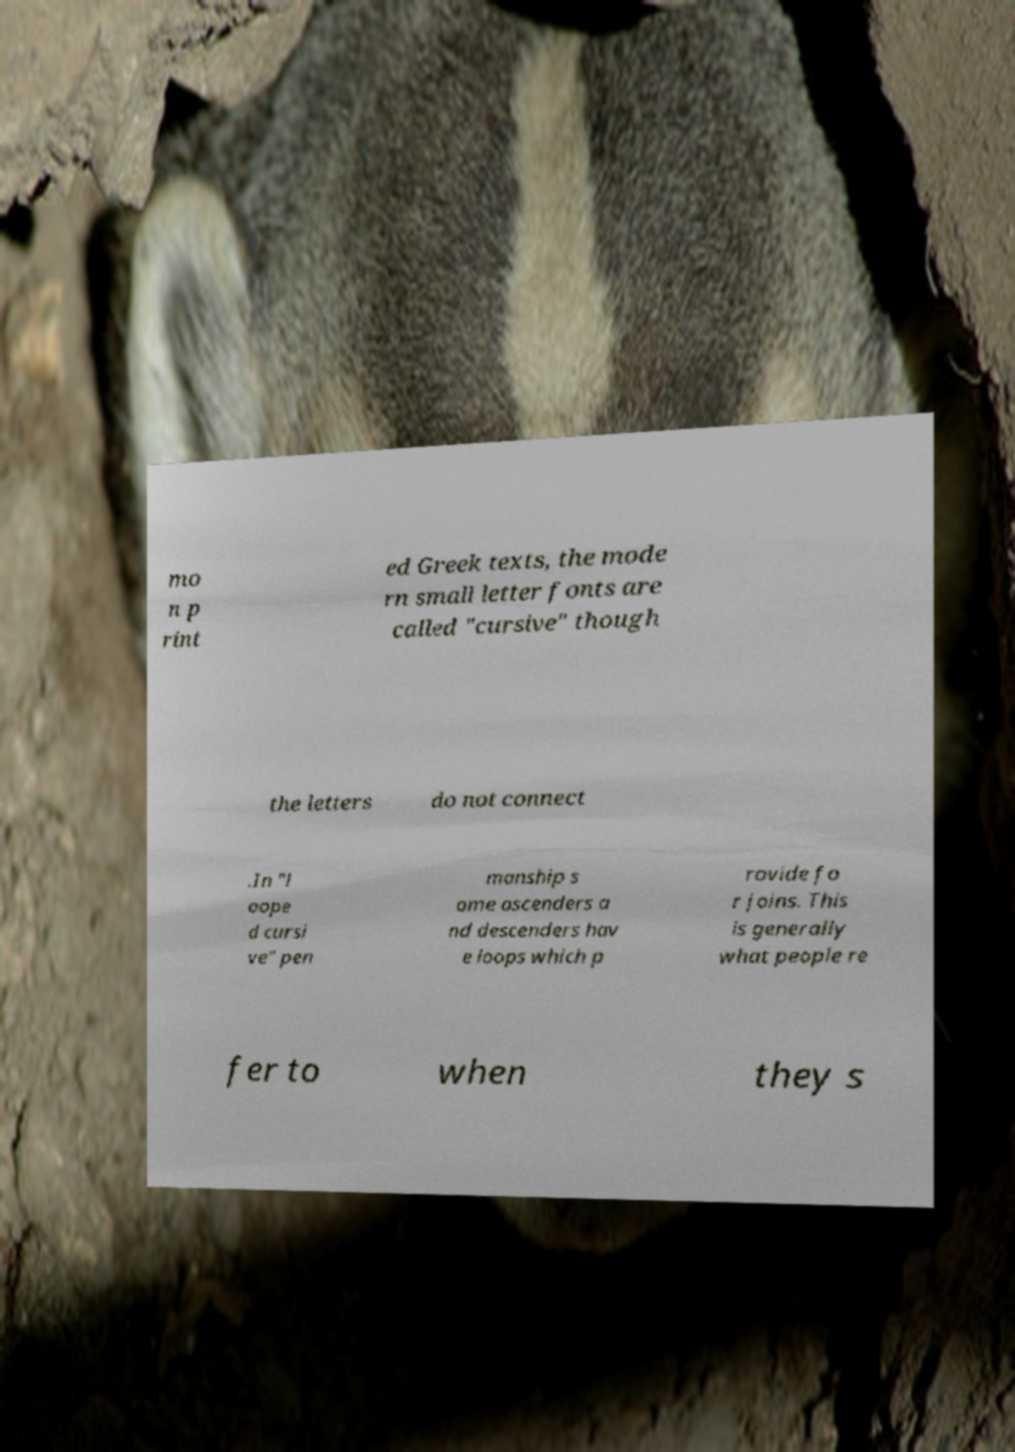Please identify and transcribe the text found in this image. mo n p rint ed Greek texts, the mode rn small letter fonts are called "cursive" though the letters do not connect .In "l oope d cursi ve" pen manship s ome ascenders a nd descenders hav e loops which p rovide fo r joins. This is generally what people re fer to when they s 